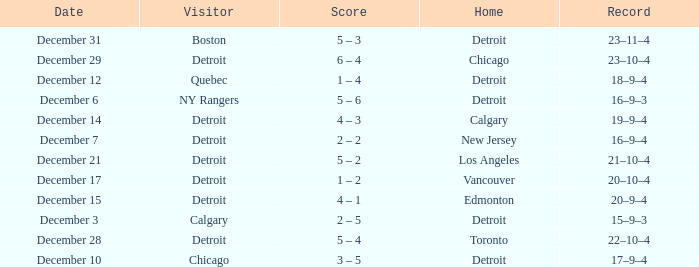What is the score on december 10? 3 – 5. 